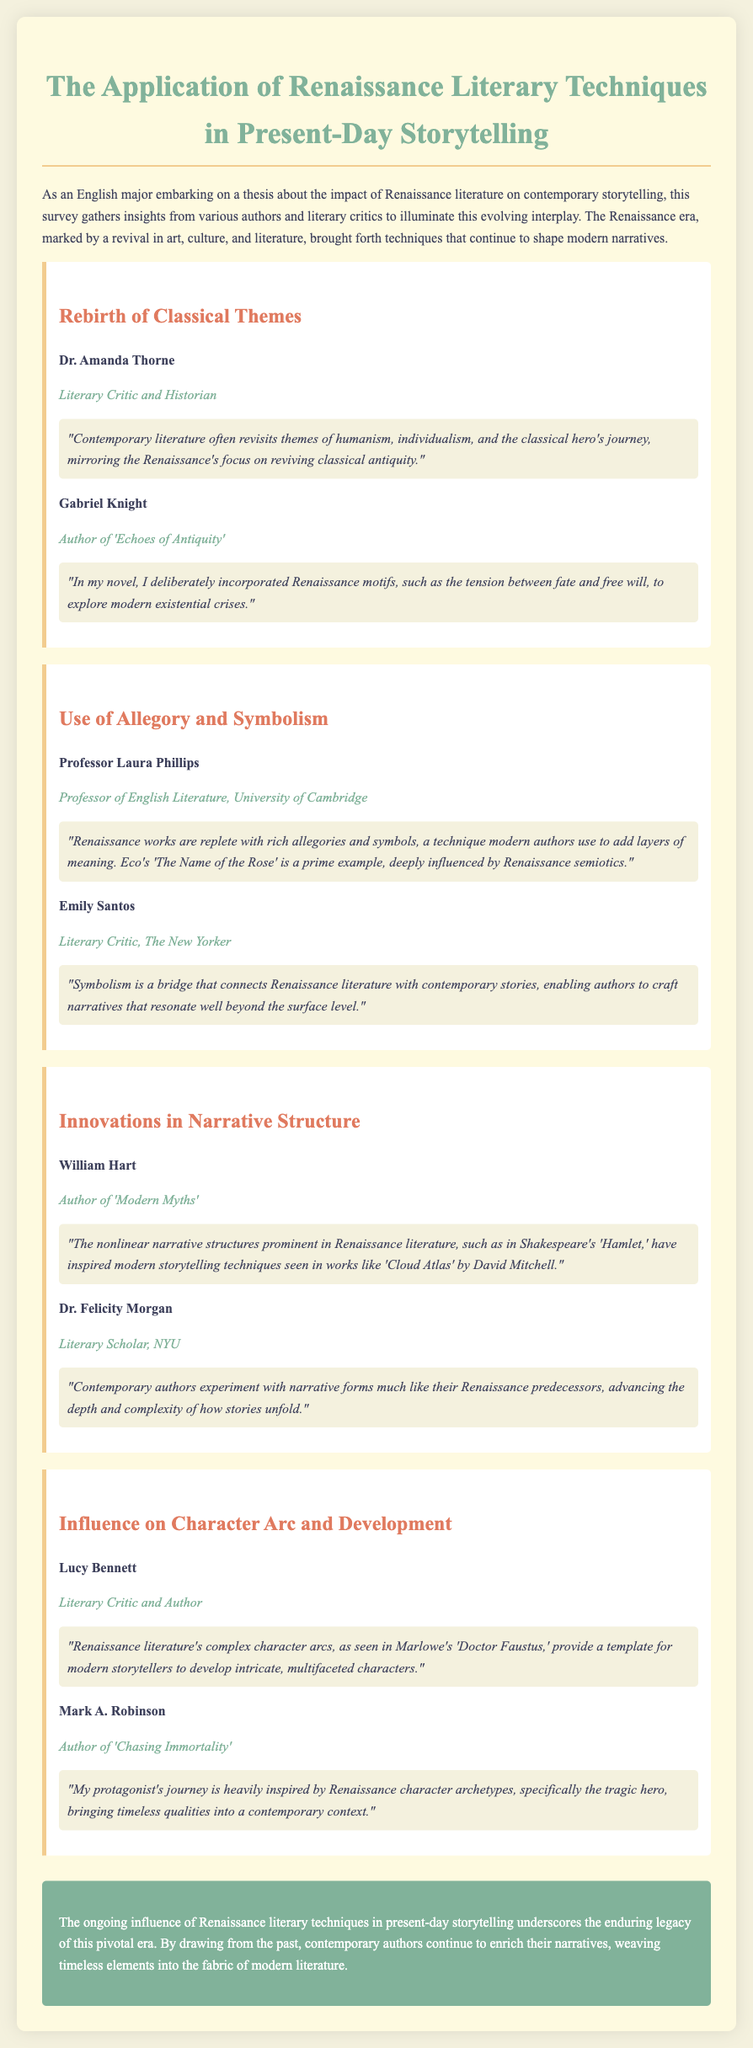What is the title of the document? The title of the document is stated at the top of the rendered page, introducing the survey's focus.
Answer: The Application of Renaissance Literary Techniques in Present-Day Storytelling Who is the author of 'Echoes of Antiquity'? The document lists Gabriel Knight as the author of 'Echoes of Antiquity' in the section about rebirth of classical themes.
Answer: Gabriel Knight Which technique do modern authors use to add layers of meaning? The document highlights that modern authors use allegory and symbolism, a technique rooted in Renaissance works, as described by critics.
Answer: Allegory and Symbolism What is a common theme revisited in contemporary literature? The document notes that contemporary literature often revisits themes central to Renaissance literature, reflecting its humanistic focus.
Answer: Humanism Who discussed nonlinear narrative structures in relation to Renaissance literature? The expert William Hart speaks about nonlinear narrative structures and their influence on modern storytelling in the section about innovations in narrative structure.
Answer: William Hart What is a significant influence of Renaissance literature on character development? The document conveys that Renaissance literature's complex character arcs serve as templates for modern storytelling.
Answer: Complex character arcs Which literary work is mentioned as an example influenced by Renaissance semiotics? The document cites Umberto Eco's 'The Name of the Rose' as a prime example influenced by Renaissance literary techniques.
Answer: The Name of the Rose Who is referenced as having a protagonist inspired by Renaissance character archetypes? The document includes Mark A. Robinson, who reflects on the influence of Renaissance archetypes in his work 'Chasing Immortality'.
Answer: Mark A. Robinson 